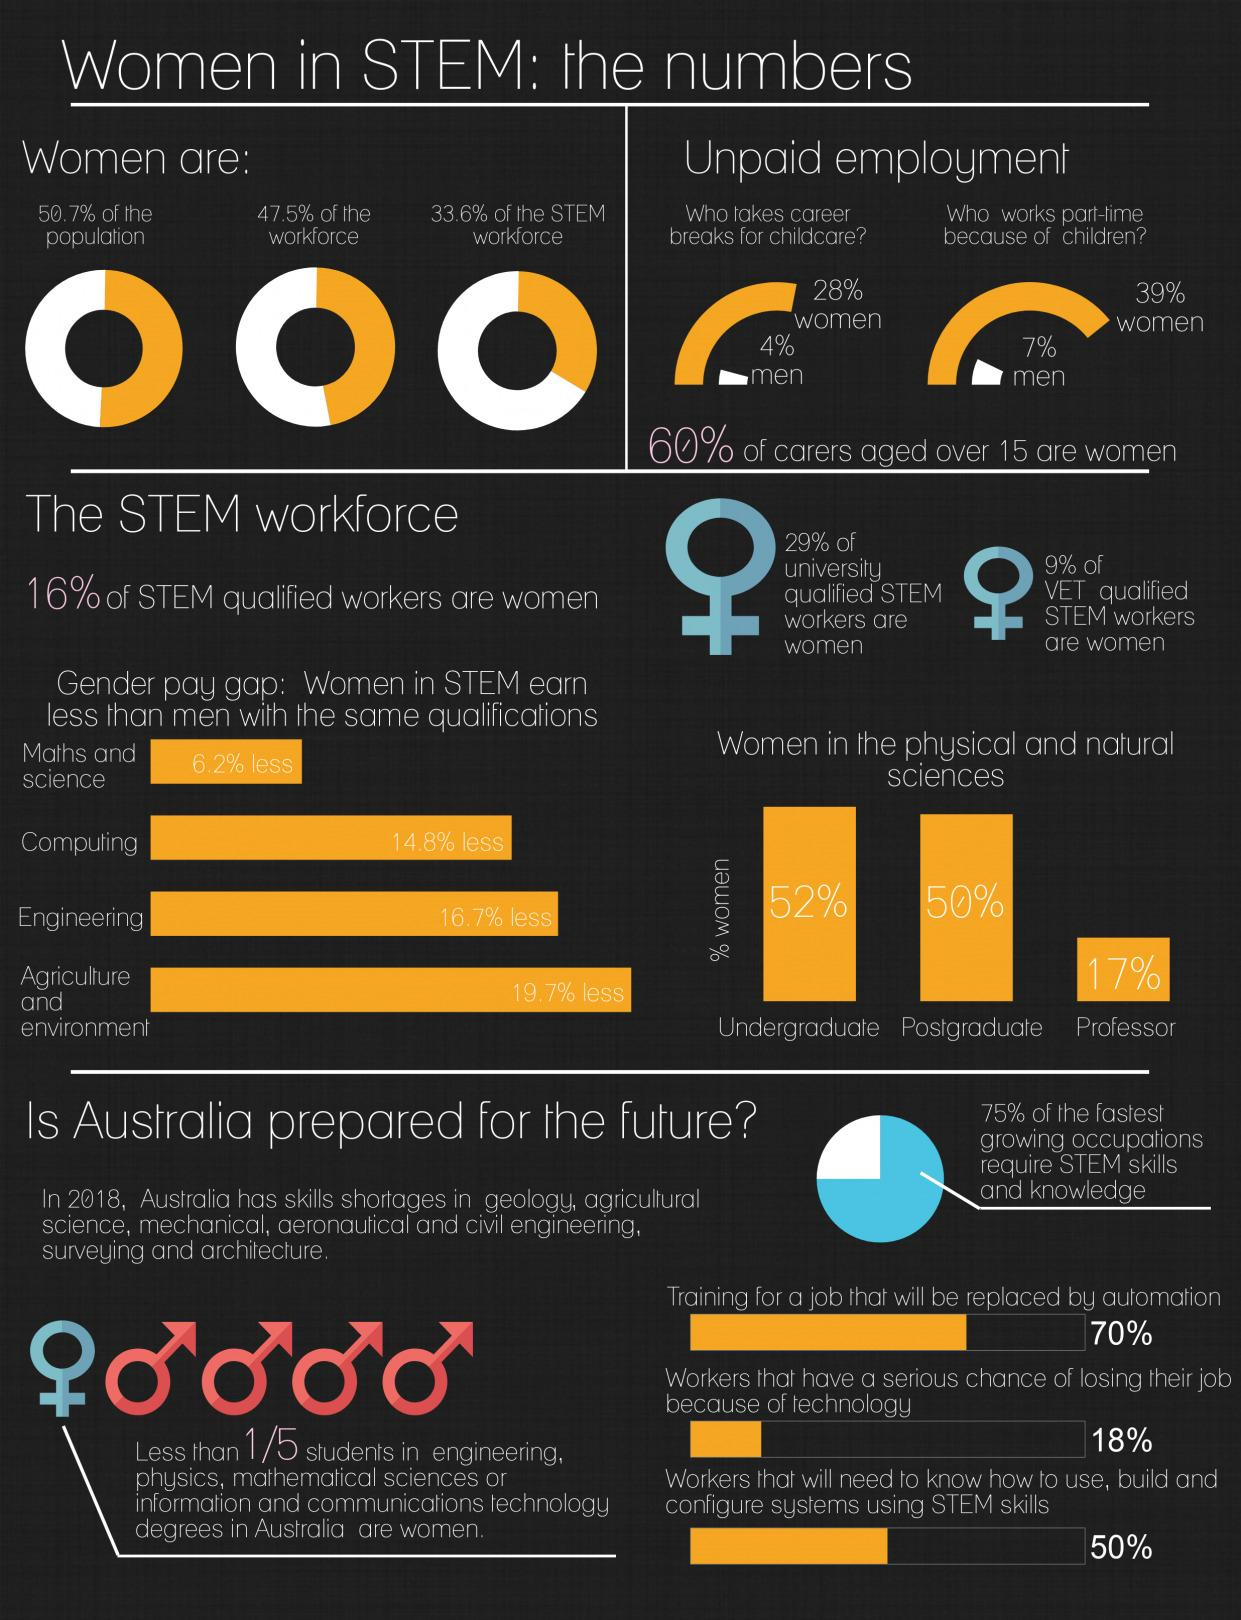Outline some significant characteristics in this image. The percentage difference in men and women taking breaks for child care is 24%. According to recent data, 33.6% of women are currently working in the STEM field, which is significantly lower than the percentages of 50.7% and 47.5%. There are 17 women out of 100 people who are professors in the physical and natural sciences. 